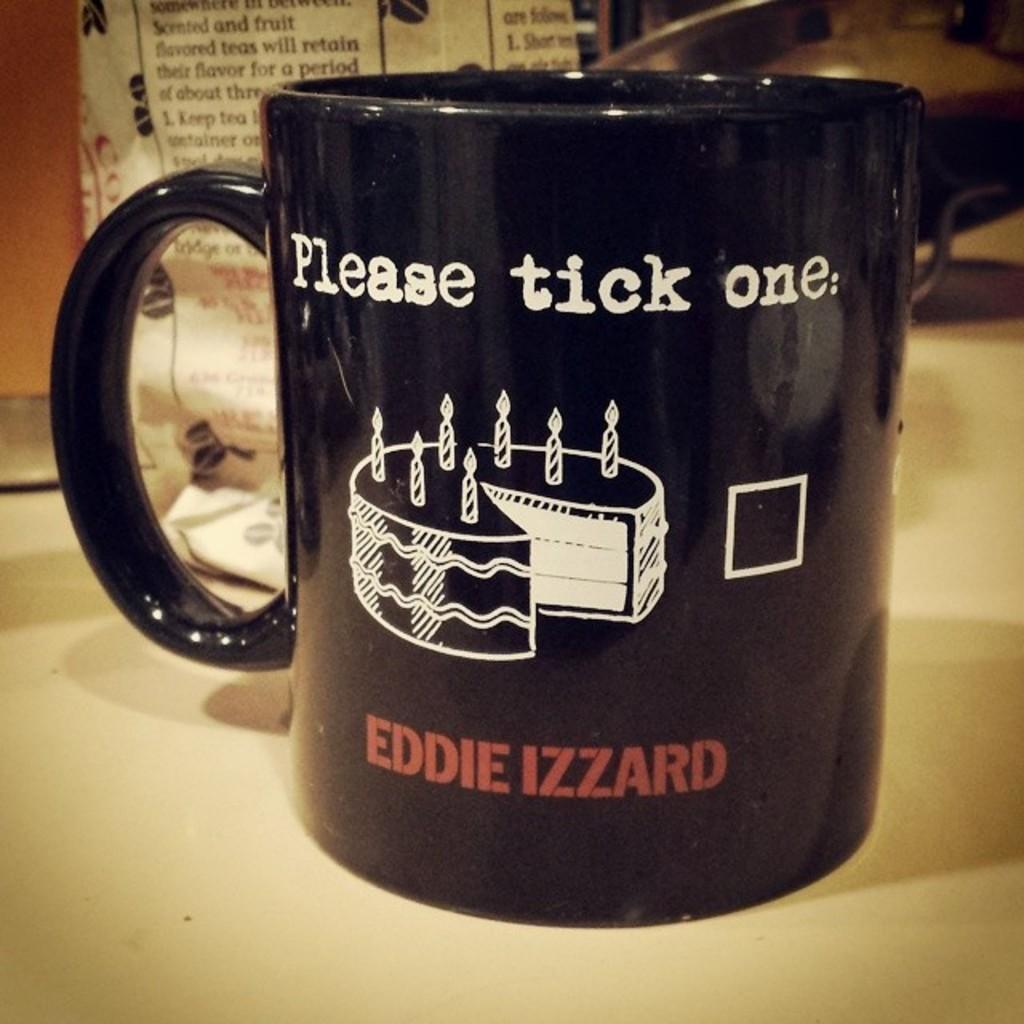Provide a one-sentence caption for the provided image. A black mug on a counter that says Please tick one. 